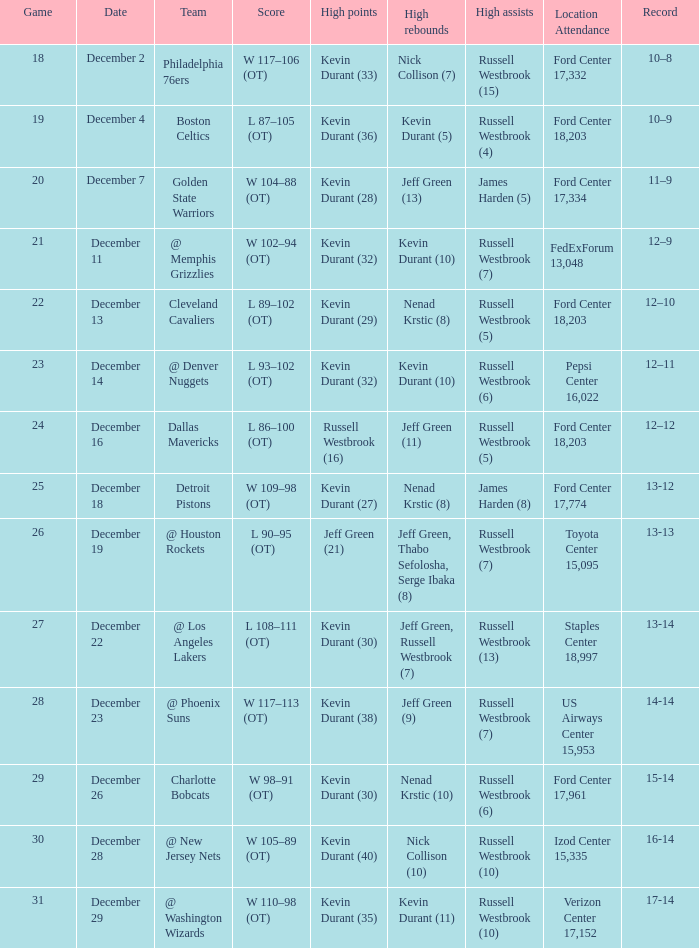Who has the highest scores when verizon center with a 17,152 seating capacity is the location for attendance? Kevin Durant (35). 